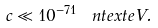Convert formula to latex. <formula><loc_0><loc_0><loc_500><loc_500>c \ll 1 0 ^ { - 7 1 } \, \ n t e x t { e V } .</formula> 